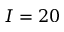<formula> <loc_0><loc_0><loc_500><loc_500>I = 2 0</formula> 